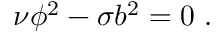<formula> <loc_0><loc_0><loc_500><loc_500>\nu \phi ^ { 2 } - \sigma b ^ { 2 } = 0 .</formula> 